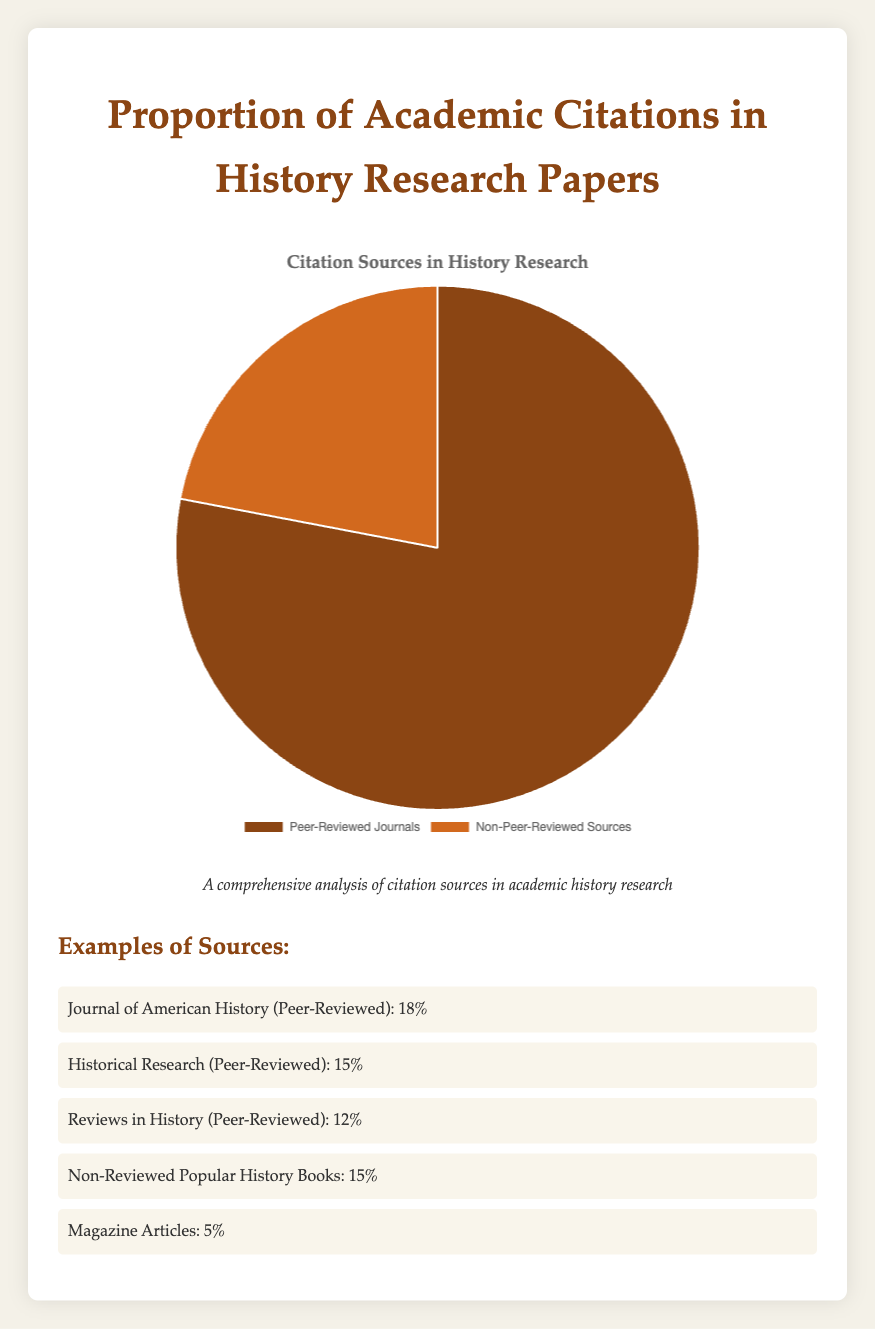What is the proportion of academic citations from peer-reviewed journals in history research papers? According to the figure, the proportion of academic citations from peer-reviewed journals is clearly indicated.
Answer: 78% What source constitutes the highest percentage of use among non-peer-reviewed sources? The figure lists "Non-Reviewed Popular History Books" as the primary non-peer-reviewed source with 15% usage.
Answer: Non-Reviewed Popular History Books What is the total percentage of citations coming from sources other than peer-reviewed journals? The figure shows a total citation percentage from non-peer-reviewed sources as 22%.
Answer: 22% By what percentage do citations from peer-reviewed journals exceed those from non-peer-reviewed sources? The figure indicates 78% for peer-reviewed journals and 22% for non-peer-reviewed sources. The difference is 78% - 22%.
Answer: 56% What is the combined percentage use of "Journal of American History" and "Historical Research"? The percentage use of "Journal of American History" is 18%, and "Historical Research" is 15%. Combined, it is 18% + 15%.
Answer: 33% Identify one data visualization element used to represent citations from non-peer-reviewed sources? The pie chart uses a distinctive color for non-peer-reviewed sources, specifically a lighter shade of brown.
Answer: Lighter shade of brown How many times more is the use of peer-reviewed journals compared to non-peer-reviewed sources? The use of peer-reviewed journals is 78% while non-peer-reviewed sources is 22%. The ratio is 78/22.
Answer: Approximately 3.55 times What category and proportion does the "Slavic Review" fall into according to the listed examples? "Slavic Review" falls under peer-reviewed journals with 9% usage.
Answer: Peer-Reviewed Journals, 9% If peer-reviewed journals make up 78% of citations, what is the average percentage use per example listed? The total percentage of peer-reviewed journal examples (18, 15, 12, 10, 9) sums to 64%. With 5 examples, the average is 64% / 5.
Answer: 12.8% Compare the percentage use of "Reviews in History" to that of "Magazine Articles". "Reviews in History" is used 12% while "Magazine Articles" is used 5%. The difference is 12% - 5%.
Answer: 7% 